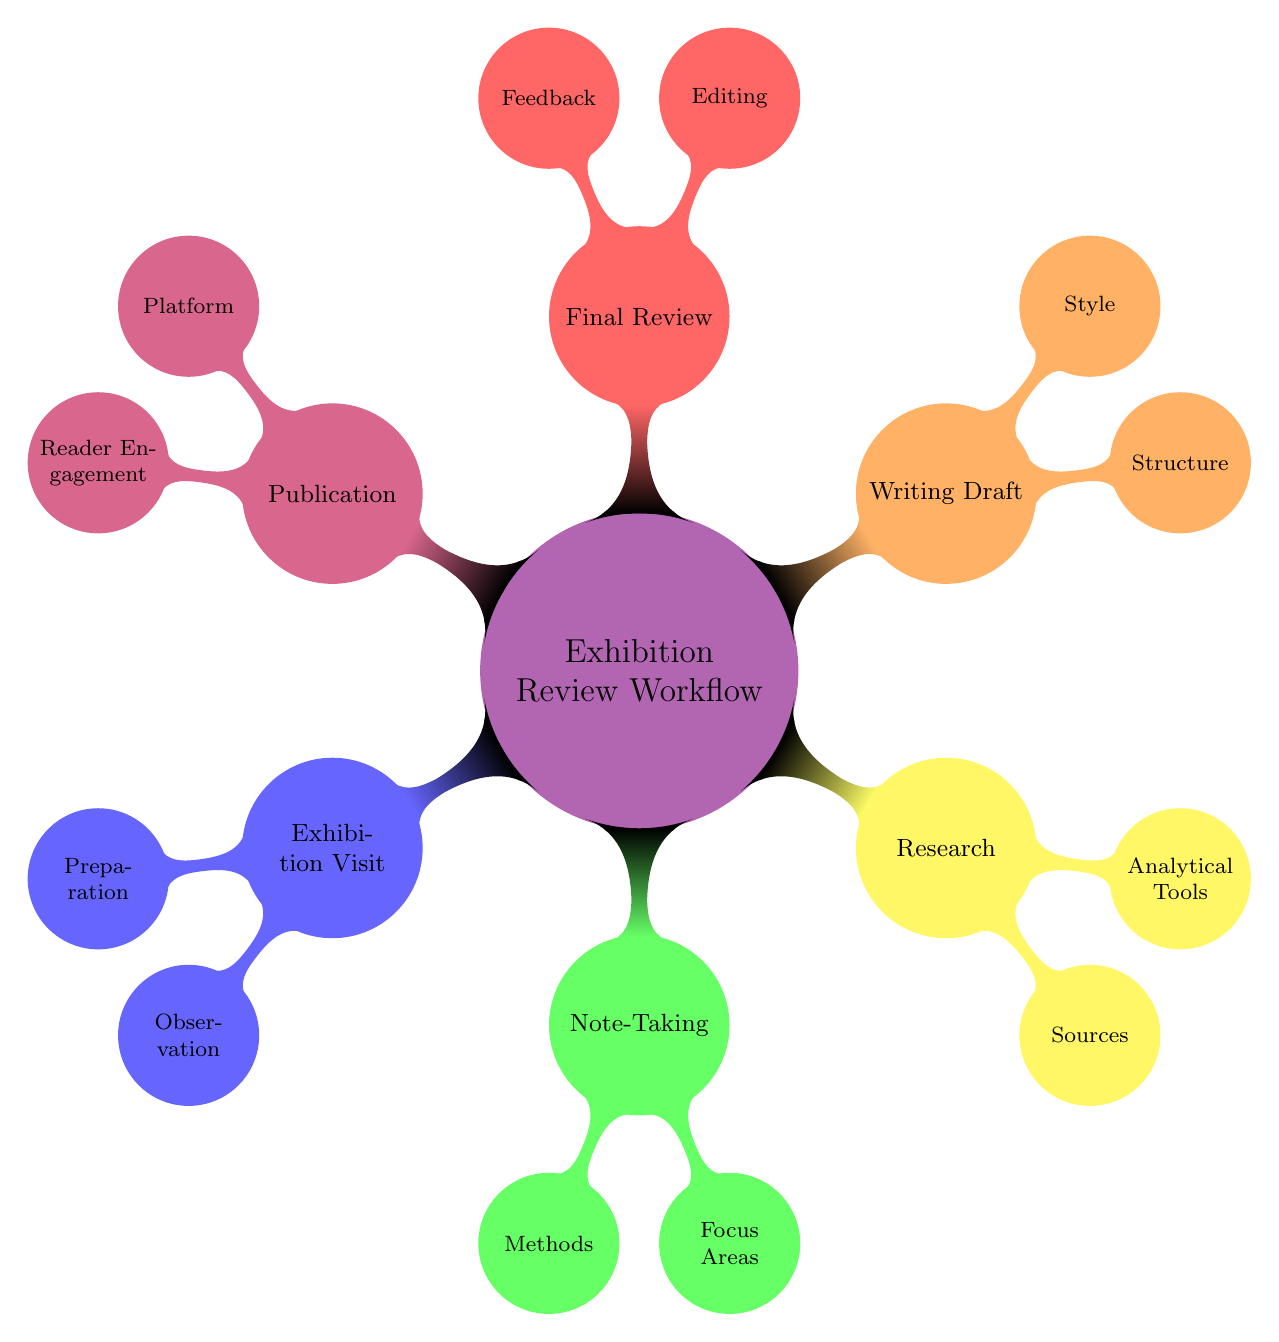What is the main topic of the mind map? The main topic is represented at the center of the diagram, which is "Exhibition Review Workflow." This can be clearly seen as the central node to which all other nodes are connected.
Answer: Exhibition Review Workflow How many main categories are in the diagram? The diagram consists of six main categories branching out from the central node. By counting the numbered child nodes connected directly to the main topic, we find there are six.
Answer: 6 What is one method under Note-Taking? Looking at the "Note-Taking" category, we can see there are two subnodes, one of which is "Digital." It is a specified method for note-taking.
Answer: Digital What are two types of Editing in the Final Review category? In the "Final Review" category, the editing subnodes include "Grammar and Spelling" and "Flow." These indicate two specific types of editing tasks involved in the review process.
Answer: Grammar and Spelling, Flow Which node has the child node "Visitor Engagement"? The "Visitor Engagement" node is a child of the "Focus Areas" under the "Note-Taking" category. This relationship is shown in the hierarchy where "Focus Areas" directly connects to "Visitor Engagement."
Answer: Note-Taking What color represents the Research category? The "Research" category is depicted in yellow, as indicated by the coloring of this section in the diagram. Each category has a distinct color, and yellow is used for Research.
Answer: Yellow Which category includes "Peer Review" under Feedback? "Peer Review" is a subnode under the "Feedback" category, which is itself a part of the "Final Review" main category. This follows the structural organization of the mind map from broad categories to specific tasks.
Answer: Final Review How many nodes are there in the Writing Draft section? The "Writing Draft" section consists of two nodes: "Structure" and "Style." By analyzing the connections in the diagram, it's clear there are two distinct subnodes in this category.
Answer: 2 What is one source listed under Research? "Exhibition catalog and brochures" is one of the sources listed under the "Sources" node in the "Research" category. This detail highlights specific materials that can be referenced when conducting research for reviews.
Answer: Exhibition catalog and brochures 